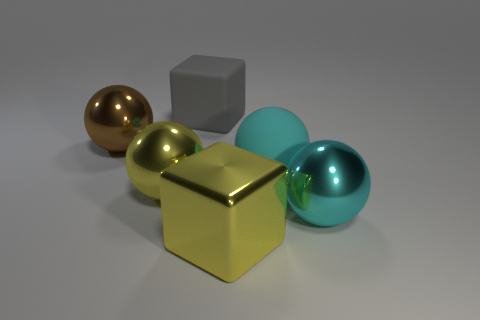Are there an equal number of big blocks in front of the large cyan rubber sphere and large gray cubes in front of the large yellow block?
Ensure brevity in your answer.  No. Is there any other thing that has the same size as the brown thing?
Ensure brevity in your answer.  Yes. The big object that is made of the same material as the big gray block is what color?
Keep it short and to the point. Cyan. Are the large gray thing and the large yellow block in front of the cyan rubber thing made of the same material?
Keep it short and to the point. No. What color is the shiny object that is behind the big yellow metal cube and right of the gray matte object?
Your response must be concise. Cyan. What number of cylinders are either big cyan metallic things or large brown objects?
Keep it short and to the point. 0. Is the shape of the cyan metal thing the same as the large yellow object that is left of the metallic cube?
Make the answer very short. Yes. What size is the shiny sphere that is both left of the big cyan matte thing and on the right side of the large brown ball?
Keep it short and to the point. Large. There is a big cyan matte thing; what shape is it?
Ensure brevity in your answer.  Sphere. Is there a large yellow metallic ball left of the thing on the left side of the yellow ball?
Keep it short and to the point. No. 